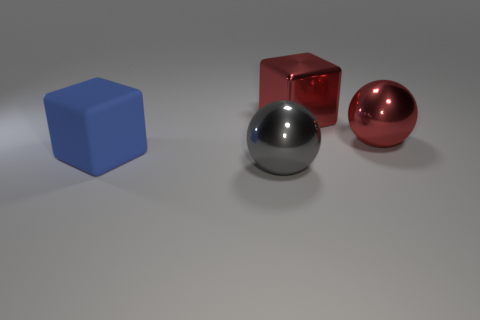Is the material of the large object right of the red block the same as the large red block?
Offer a terse response. Yes. What color is the shiny block that is the same size as the blue rubber block?
Your answer should be very brief. Red. Is there another metallic thing of the same shape as the large gray object?
Offer a terse response. Yes. There is a large metal thing in front of the sphere right of the metallic object left of the big metallic block; what color is it?
Ensure brevity in your answer.  Gray. What number of shiny objects are either red blocks or big red objects?
Offer a very short reply. 2. Are there more big metal things that are left of the big matte block than blue matte things behind the gray metallic ball?
Your answer should be very brief. No. How many other objects are the same size as the red block?
Offer a very short reply. 3. What is the size of the sphere that is in front of the sphere that is behind the blue block?
Your answer should be compact. Large. What number of big things are red blocks or gray balls?
Offer a very short reply. 2. How big is the cube on the right side of the thing that is to the left of the large shiny object that is in front of the matte cube?
Your answer should be compact. Large. 